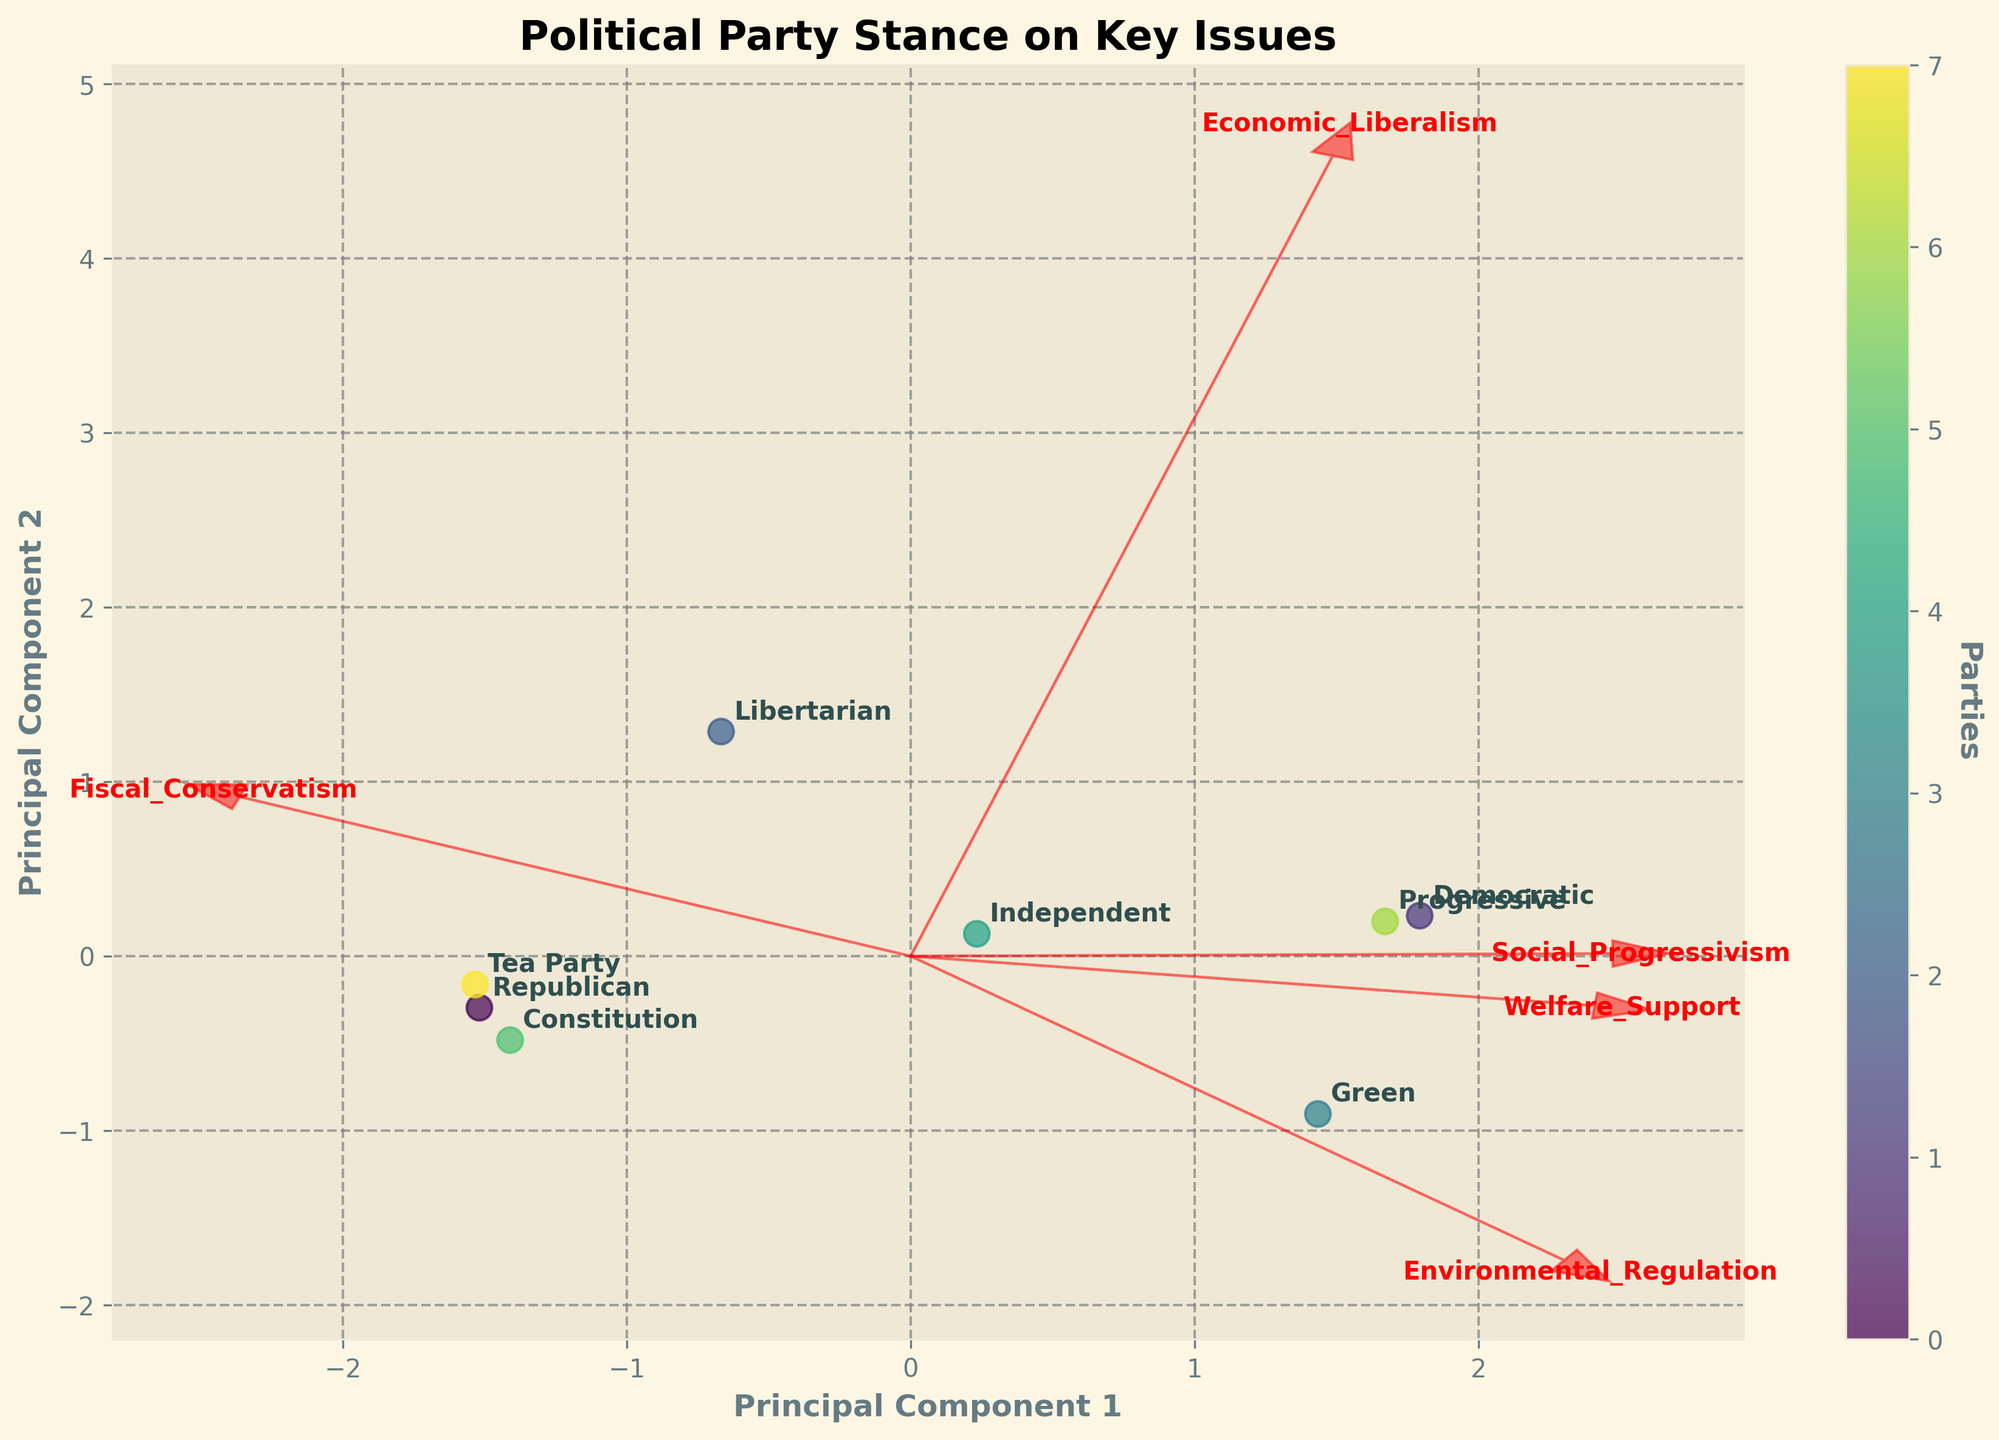Which political party is positioned closest to the origin of the biplot? Look for the party whose data point is nearest to the (0,0) coordinates on the plot. The Independent party is closest to the origin.
Answer: Independent Which party has the most positive stance on both economic liberalism and social progressivism? Identify the party placed in the upper right quadrant of the plot, furthest from the origin. The Democratic party is positioned highest on both dimensions.
Answer: Democratic Which features are most aligned with Principal Component 1? Examine the feature vectors and identify those with the longest arrows along the PC1 axis. Both Economic Liberalism and Fiscal Conservatism are heavily aligned with PC1.
Answer: Economic Liberalism, Fiscal Conservatism How do the Republican and Tea Party stances compare in terms of social progressivism? Compare the vertical positions (PC2 values) of the Republican and Tea Party points on the plot. Both are in the lower part of the graph, indicating similar, negative stances on social progressivism.
Answer: Similar negative stance on social progressivism Which party leans most heavily towards welfare support? Look for the party located furthest in the direction of the Welfare Support vector. The Democratic party is positioned closest to the Welfare Support arrow.
Answer: Democratic Are the stances of the Libertarian and Progressive parties similar or different? Identify and compare the positions of the Libertarian and Progressive data points on both dimensions (PC1 and PC2). Libertarians are positioned differently from Progressives, being more economically liberal and less socially progressive.
Answer: Different Which party is most opposed to environmental regulation? Locate the party furthest in the opposite direction of the Environmental Regulation vector. The Libertarian party is placed farthest in that direction, indicating the most opposition.
Answer: Libertarian Which features are less influential in defining Principal Component 2? Examine the feature vectors oriented more horizontally and shorter in length along PC2. Economic Liberalism and Fiscal Conservatism have lesser influence on PC2.
Answer: Economic Liberalism, Fiscal Conservatism What becomes clear about political stances by looking at the Green and Constitution parties? Compare the positions of the Green and Constitution parties, noting their extreme distances on social progressivism and environmental regulation stances. The Green party is extremely positive on social progressivism and environmental regulation, while the Constitution party is extremely negative on those.
Answer: Green is very progressive and pro-environment, Constitution is conservative and anti-environment How does the stance of the Progressive party compare to the Democratic party on fiscal conservatism? Consider the position of the Progressive party relative to the Democratic party along the Fiscal Conservatism dimension. Both are similar in fiscal conservatism but the Progressive party is slightly less opposed than the Democratic party.
Answer: Slightly less opposed 